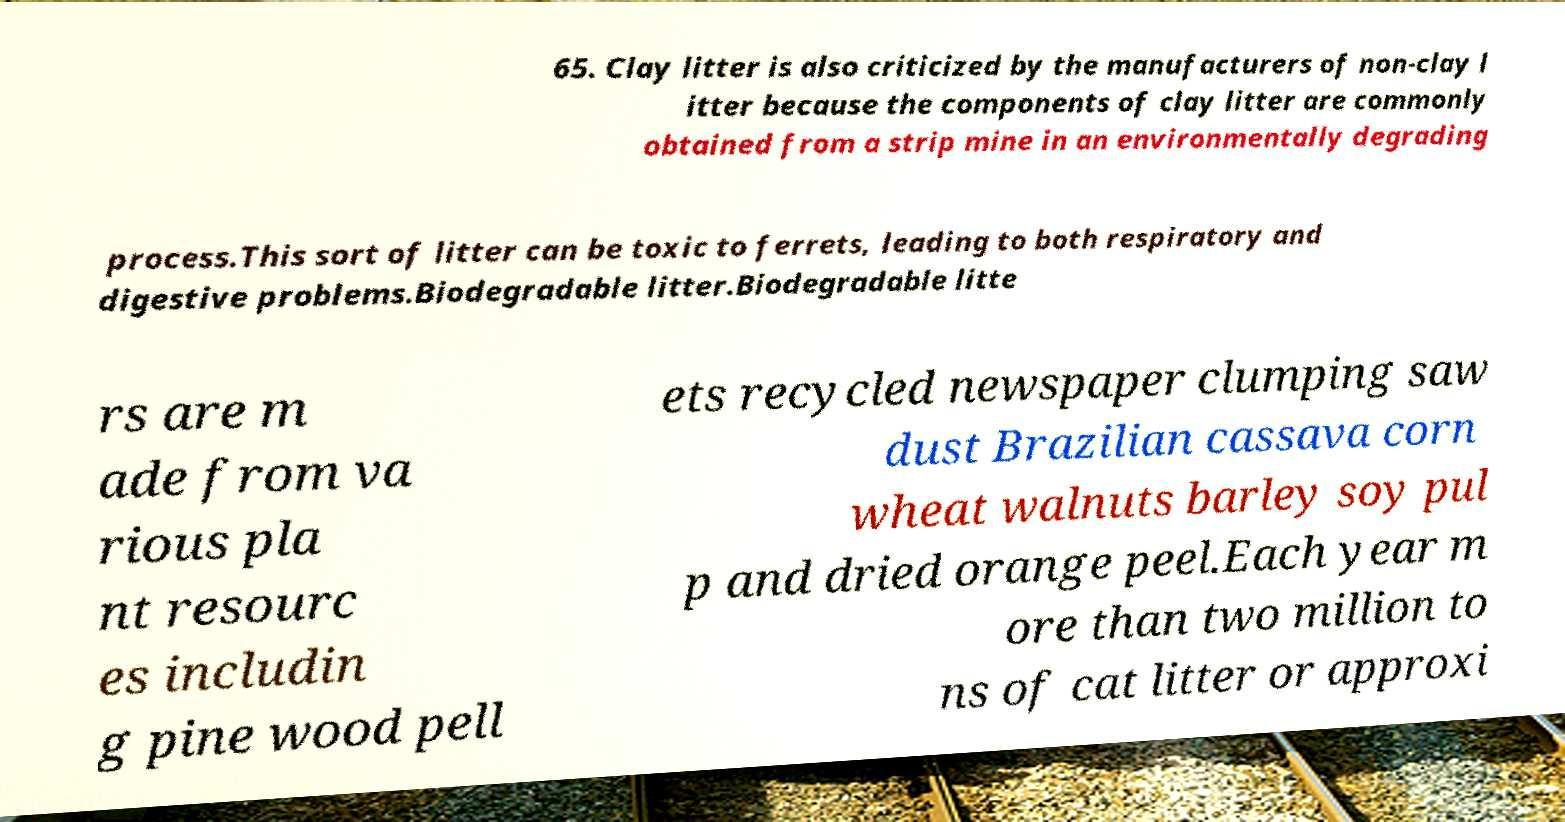I need the written content from this picture converted into text. Can you do that? 65. Clay litter is also criticized by the manufacturers of non-clay l itter because the components of clay litter are commonly obtained from a strip mine in an environmentally degrading process.This sort of litter can be toxic to ferrets, leading to both respiratory and digestive problems.Biodegradable litter.Biodegradable litte rs are m ade from va rious pla nt resourc es includin g pine wood pell ets recycled newspaper clumping saw dust Brazilian cassava corn wheat walnuts barley soy pul p and dried orange peel.Each year m ore than two million to ns of cat litter or approxi 